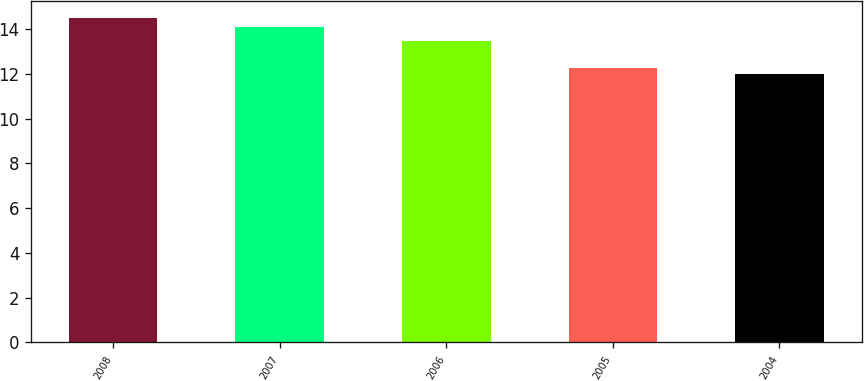Convert chart to OTSL. <chart><loc_0><loc_0><loc_500><loc_500><bar_chart><fcel>2008<fcel>2007<fcel>2006<fcel>2005<fcel>2004<nl><fcel>14.52<fcel>14.12<fcel>13.48<fcel>12.25<fcel>12<nl></chart> 